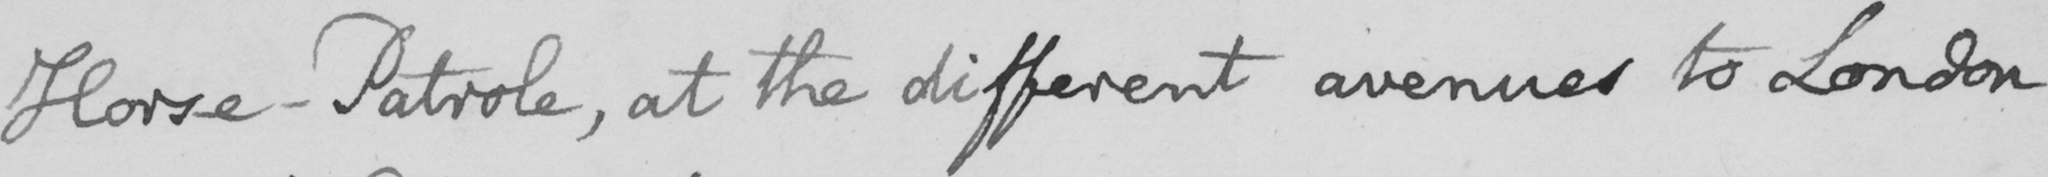Can you read and transcribe this handwriting? Horse Patrole , at the different avenues to London 